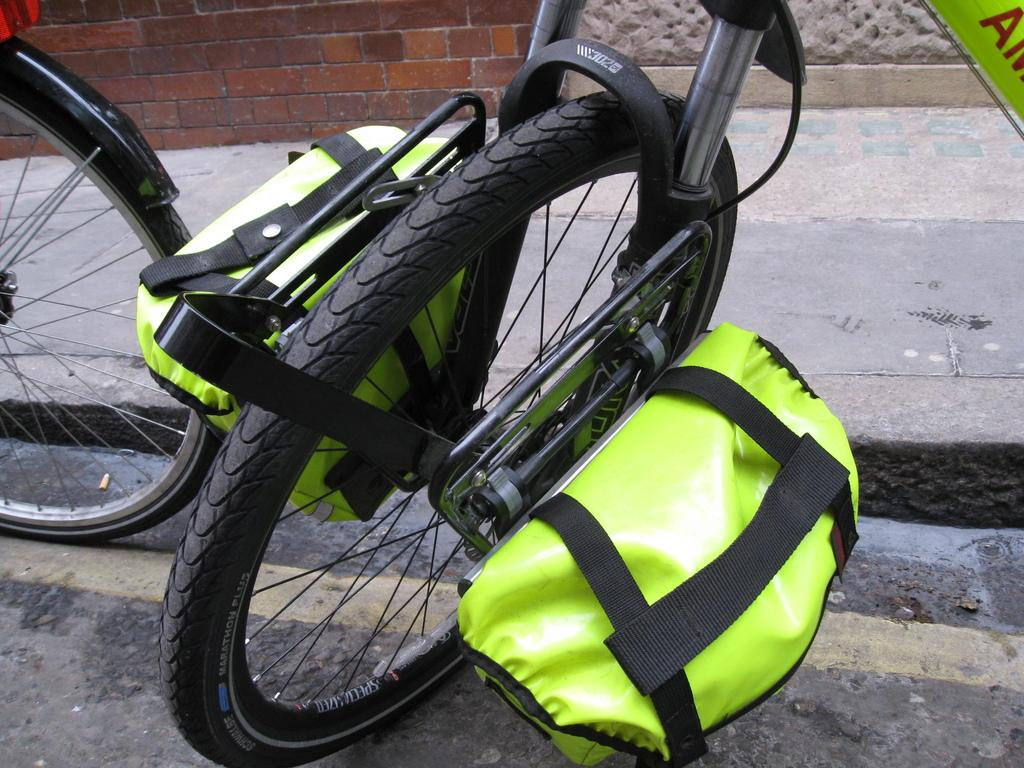What can be seen on the road in the image? There are two bicycles on the road in the image. What is unique about one of the bicycles? One of the bicycles has green color bags attached to a wheel. What is located beside the road in the image? There is a footpath beside the road. What is visible at the top of the image? There is a wall visible at the top of the image. What type of hammer is being used by the person riding the bicycle? There is no hammer present in the image, and no person is riding the bicycles. 